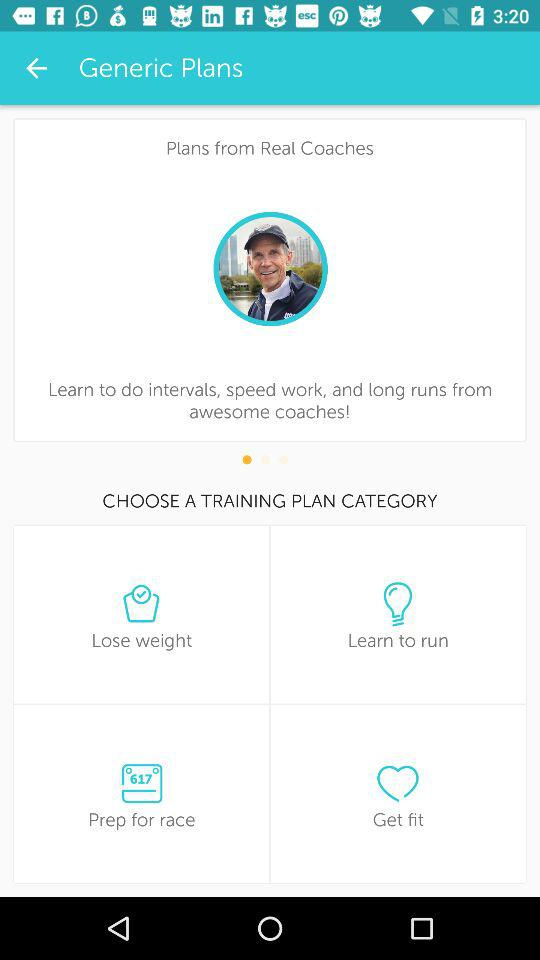What are the options available in "TRAINING PLAN"? The options are "Lose weight", "Learn to run", "Prep for race" and "Get fit". 